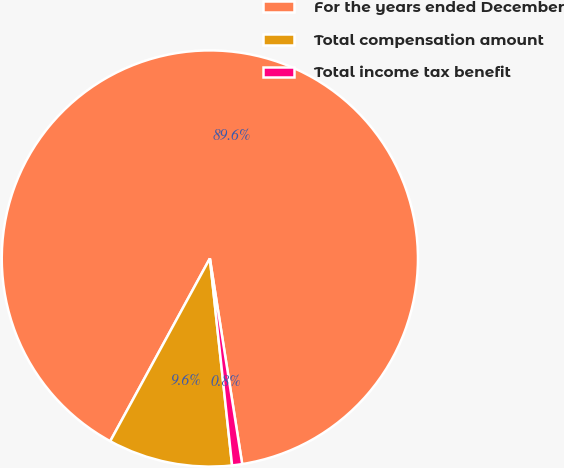Convert chart. <chart><loc_0><loc_0><loc_500><loc_500><pie_chart><fcel>For the years ended December<fcel>Total compensation amount<fcel>Total income tax benefit<nl><fcel>89.57%<fcel>9.65%<fcel>0.78%<nl></chart> 